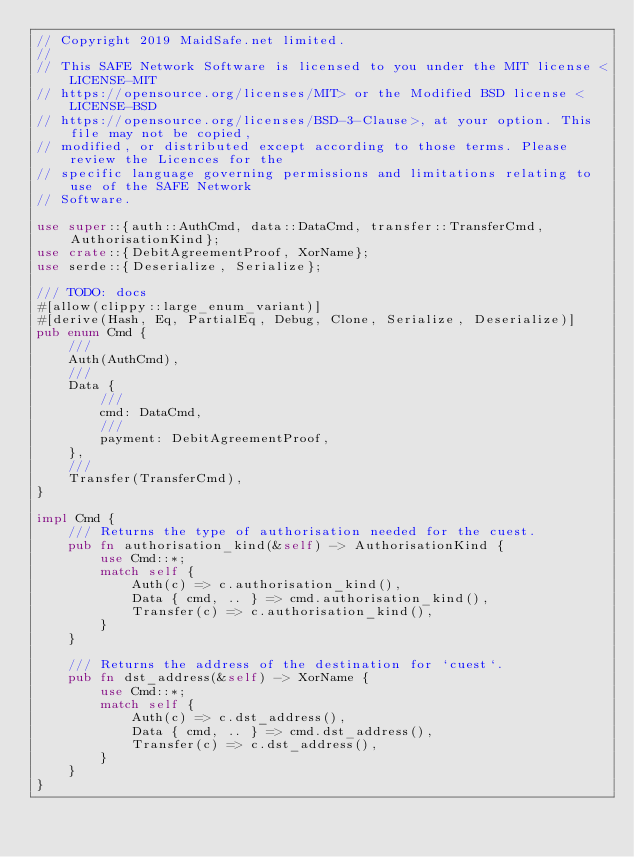<code> <loc_0><loc_0><loc_500><loc_500><_Rust_>// Copyright 2019 MaidSafe.net limited.
//
// This SAFE Network Software is licensed to you under the MIT license <LICENSE-MIT
// https://opensource.org/licenses/MIT> or the Modified BSD license <LICENSE-BSD
// https://opensource.org/licenses/BSD-3-Clause>, at your option. This file may not be copied,
// modified, or distributed except according to those terms. Please review the Licences for the
// specific language governing permissions and limitations relating to use of the SAFE Network
// Software.

use super::{auth::AuthCmd, data::DataCmd, transfer::TransferCmd, AuthorisationKind};
use crate::{DebitAgreementProof, XorName};
use serde::{Deserialize, Serialize};

/// TODO: docs
#[allow(clippy::large_enum_variant)]
#[derive(Hash, Eq, PartialEq, Debug, Clone, Serialize, Deserialize)]
pub enum Cmd {
    ///
    Auth(AuthCmd),
    ///
    Data {
        ///
        cmd: DataCmd,
        ///
        payment: DebitAgreementProof,
    },
    ///
    Transfer(TransferCmd),
}

impl Cmd {
    /// Returns the type of authorisation needed for the cuest.
    pub fn authorisation_kind(&self) -> AuthorisationKind {
        use Cmd::*;
        match self {
            Auth(c) => c.authorisation_kind(),
            Data { cmd, .. } => cmd.authorisation_kind(),
            Transfer(c) => c.authorisation_kind(),
        }
    }

    /// Returns the address of the destination for `cuest`.
    pub fn dst_address(&self) -> XorName {
        use Cmd::*;
        match self {
            Auth(c) => c.dst_address(),
            Data { cmd, .. } => cmd.dst_address(),
            Transfer(c) => c.dst_address(),
        }
    }
}
</code> 